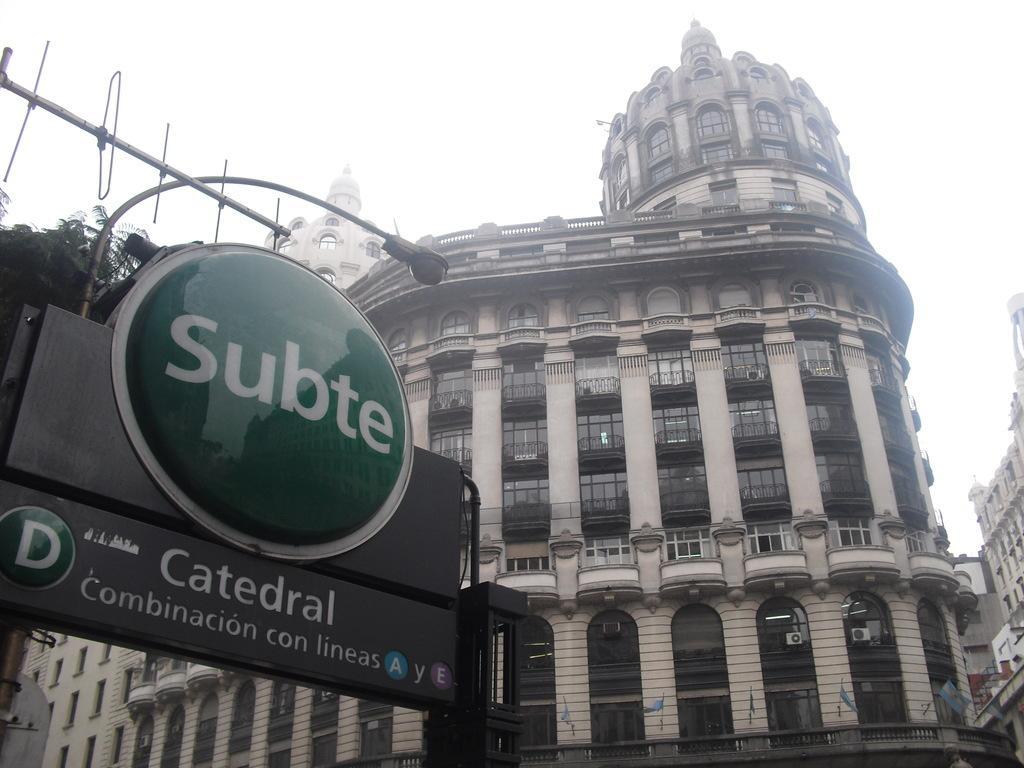In one or two sentences, can you explain what this image depicts? On the left side, there are sign boards and a light attached to a pole. In the background, there are buildings having windows and there is sky. 